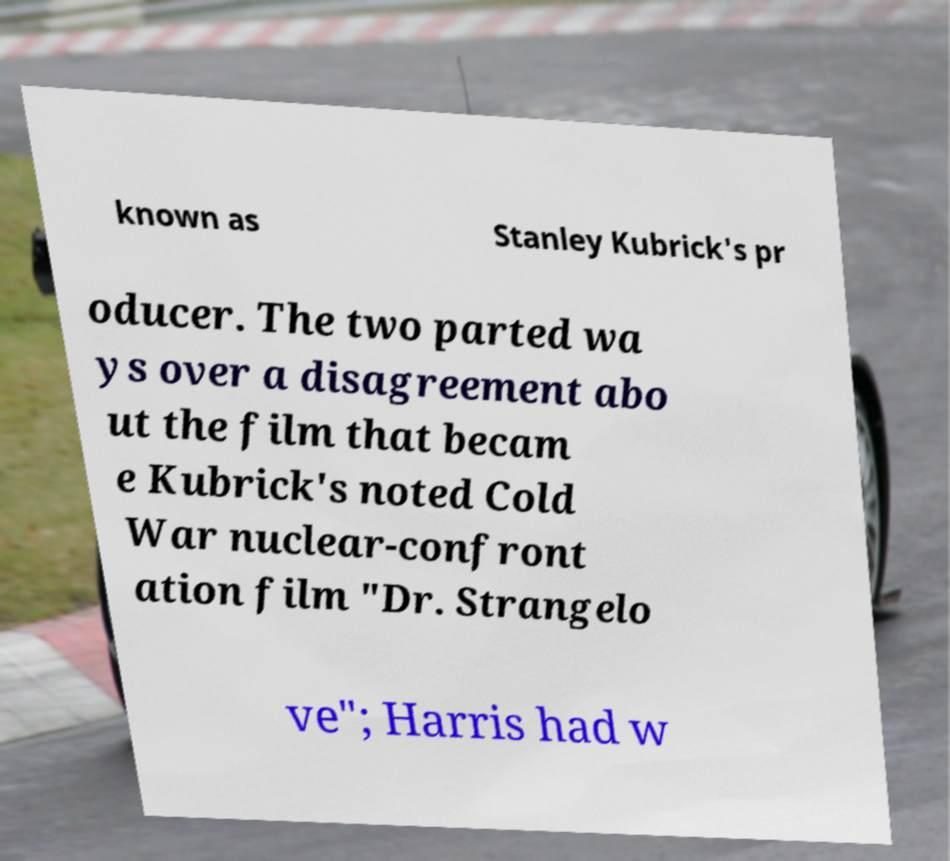What messages or text are displayed in this image? I need them in a readable, typed format. known as Stanley Kubrick's pr oducer. The two parted wa ys over a disagreement abo ut the film that becam e Kubrick's noted Cold War nuclear-confront ation film "Dr. Strangelo ve"; Harris had w 